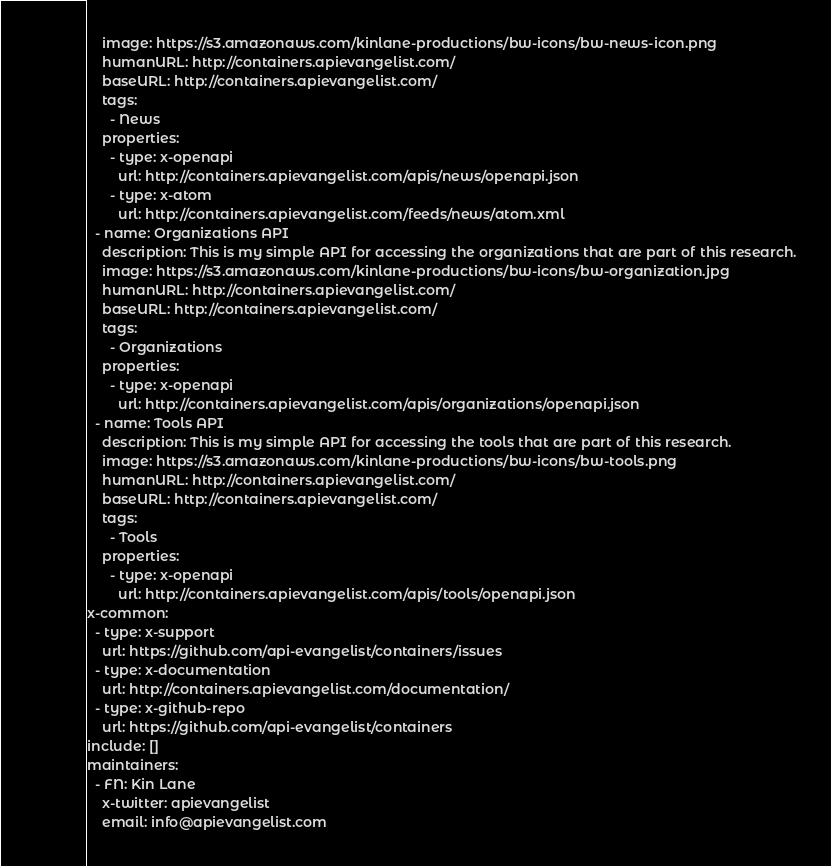<code> <loc_0><loc_0><loc_500><loc_500><_YAML_>    image: https://s3.amazonaws.com/kinlane-productions/bw-icons/bw-news-icon.png
    humanURL: http://containers.apievangelist.com/
    baseURL: http://containers.apievangelist.com/
    tags:
      - News
    properties:
      - type: x-openapi
        url: http://containers.apievangelist.com/apis/news/openapi.json
      - type: x-atom
        url: http://containers.apievangelist.com/feeds/news/atom.xml
  - name: Organizations API
    description: This is my simple API for accessing the organizations that are part of this research.
    image: https://s3.amazonaws.com/kinlane-productions/bw-icons/bw-organization.jpg
    humanURL: http://containers.apievangelist.com/
    baseURL: http://containers.apievangelist.com/
    tags:
      - Organizations
    properties:
      - type: x-openapi
        url: http://containers.apievangelist.com/apis/organizations/openapi.json
  - name: Tools API
    description: This is my simple API for accessing the tools that are part of this research.
    image: https://s3.amazonaws.com/kinlane-productions/bw-icons/bw-tools.png
    humanURL: http://containers.apievangelist.com/
    baseURL: http://containers.apievangelist.com/
    tags:
      - Tools
    properties:
      - type: x-openapi
        url: http://containers.apievangelist.com/apis/tools/openapi.json
x-common:
  - type: x-support
    url: https://github.com/api-evangelist/containers/issues
  - type: x-documentation
    url: http://containers.apievangelist.com/documentation/
  - type: x-github-repo
    url: https://github.com/api-evangelist/containers
include: []
maintainers:
  - FN: Kin Lane
    x-twitter: apievangelist
    email: info@apievangelist.com
</code> 